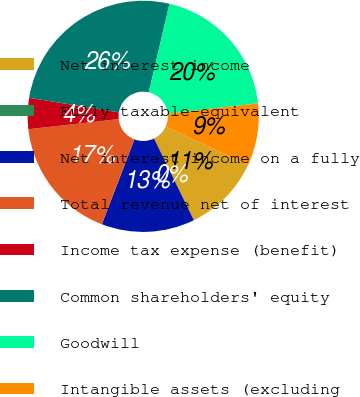Convert chart. <chart><loc_0><loc_0><loc_500><loc_500><pie_chart><fcel>Net interest income<fcel>Fully taxable-equivalent<fcel>Net interest income on a fully<fcel>Total revenue net of interest<fcel>Income tax expense (benefit)<fcel>Common shareholders' equity<fcel>Goodwill<fcel>Intangible assets (excluding<nl><fcel>10.87%<fcel>0.0%<fcel>13.04%<fcel>17.39%<fcel>4.35%<fcel>26.08%<fcel>19.56%<fcel>8.7%<nl></chart> 